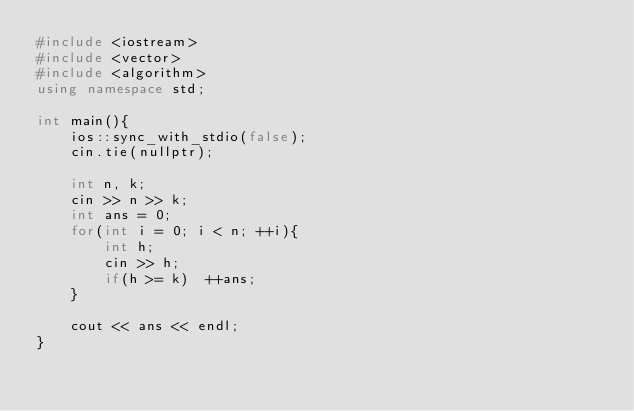Convert code to text. <code><loc_0><loc_0><loc_500><loc_500><_C++_>#include <iostream>
#include <vector>
#include <algorithm>
using namespace std;

int main(){
    ios::sync_with_stdio(false);
    cin.tie(nullptr);
    
    int n, k;
    cin >> n >> k;
    int ans = 0;
    for(int i = 0; i < n; ++i){
        int h;
        cin >> h;
        if(h >= k)  ++ans;
    }
    
    cout << ans << endl;
}</code> 